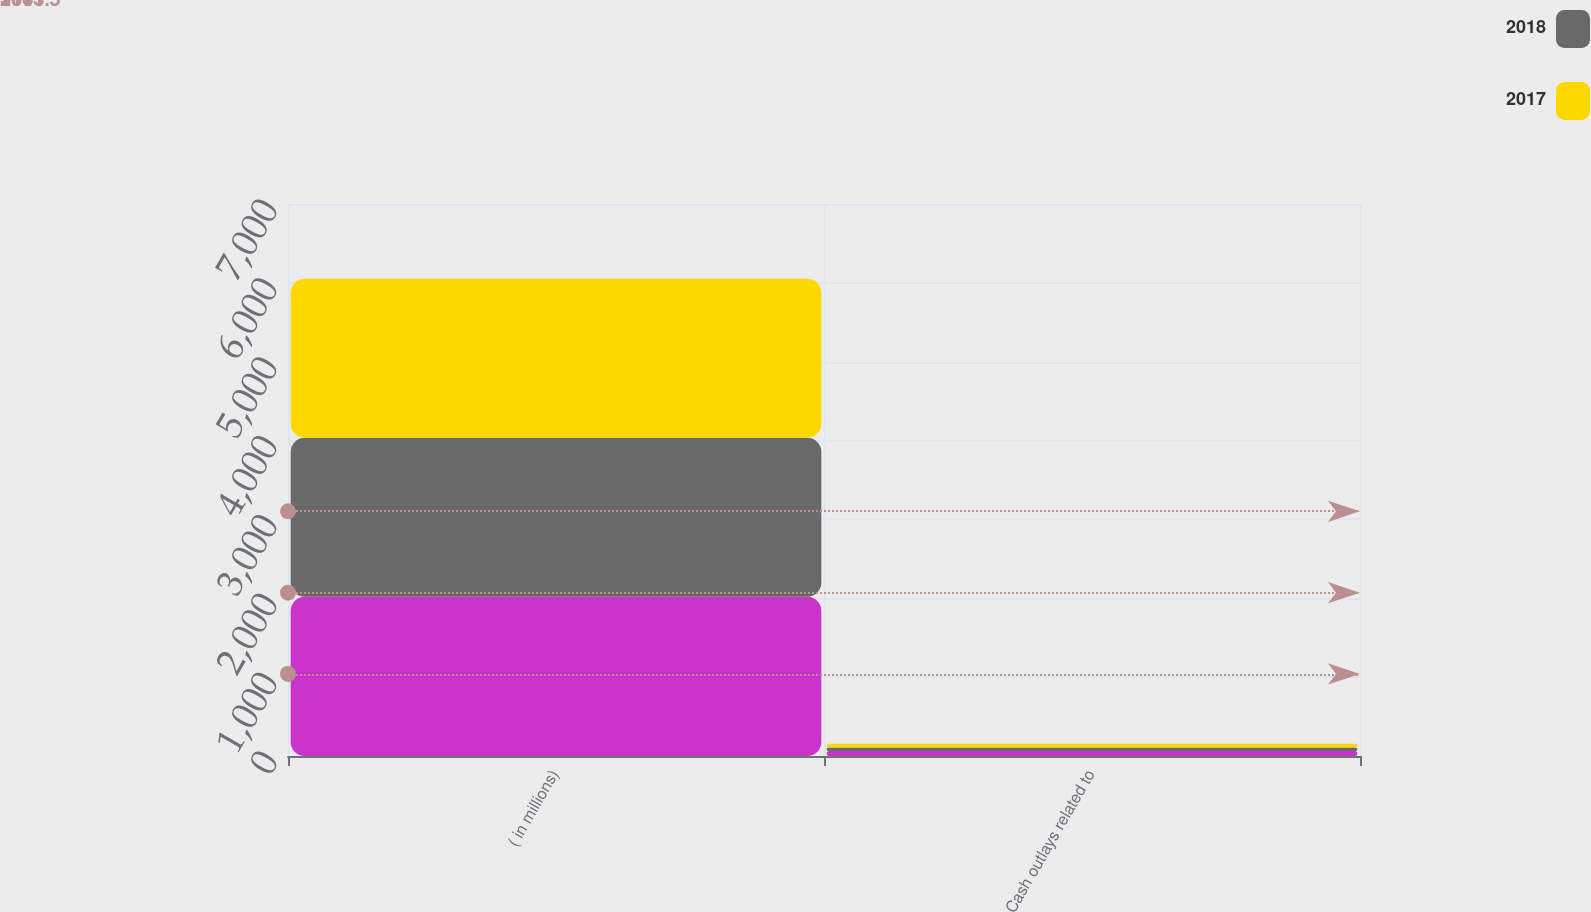Convert chart to OTSL. <chart><loc_0><loc_0><loc_500><loc_500><stacked_bar_chart><ecel><fcel>( in millions)<fcel>Cash outlays related to<nl><fcel>nan<fcel>2018<fcel>64<nl><fcel>2018<fcel>2017<fcel>44<nl><fcel>2017<fcel>2016<fcel>47<nl></chart> 